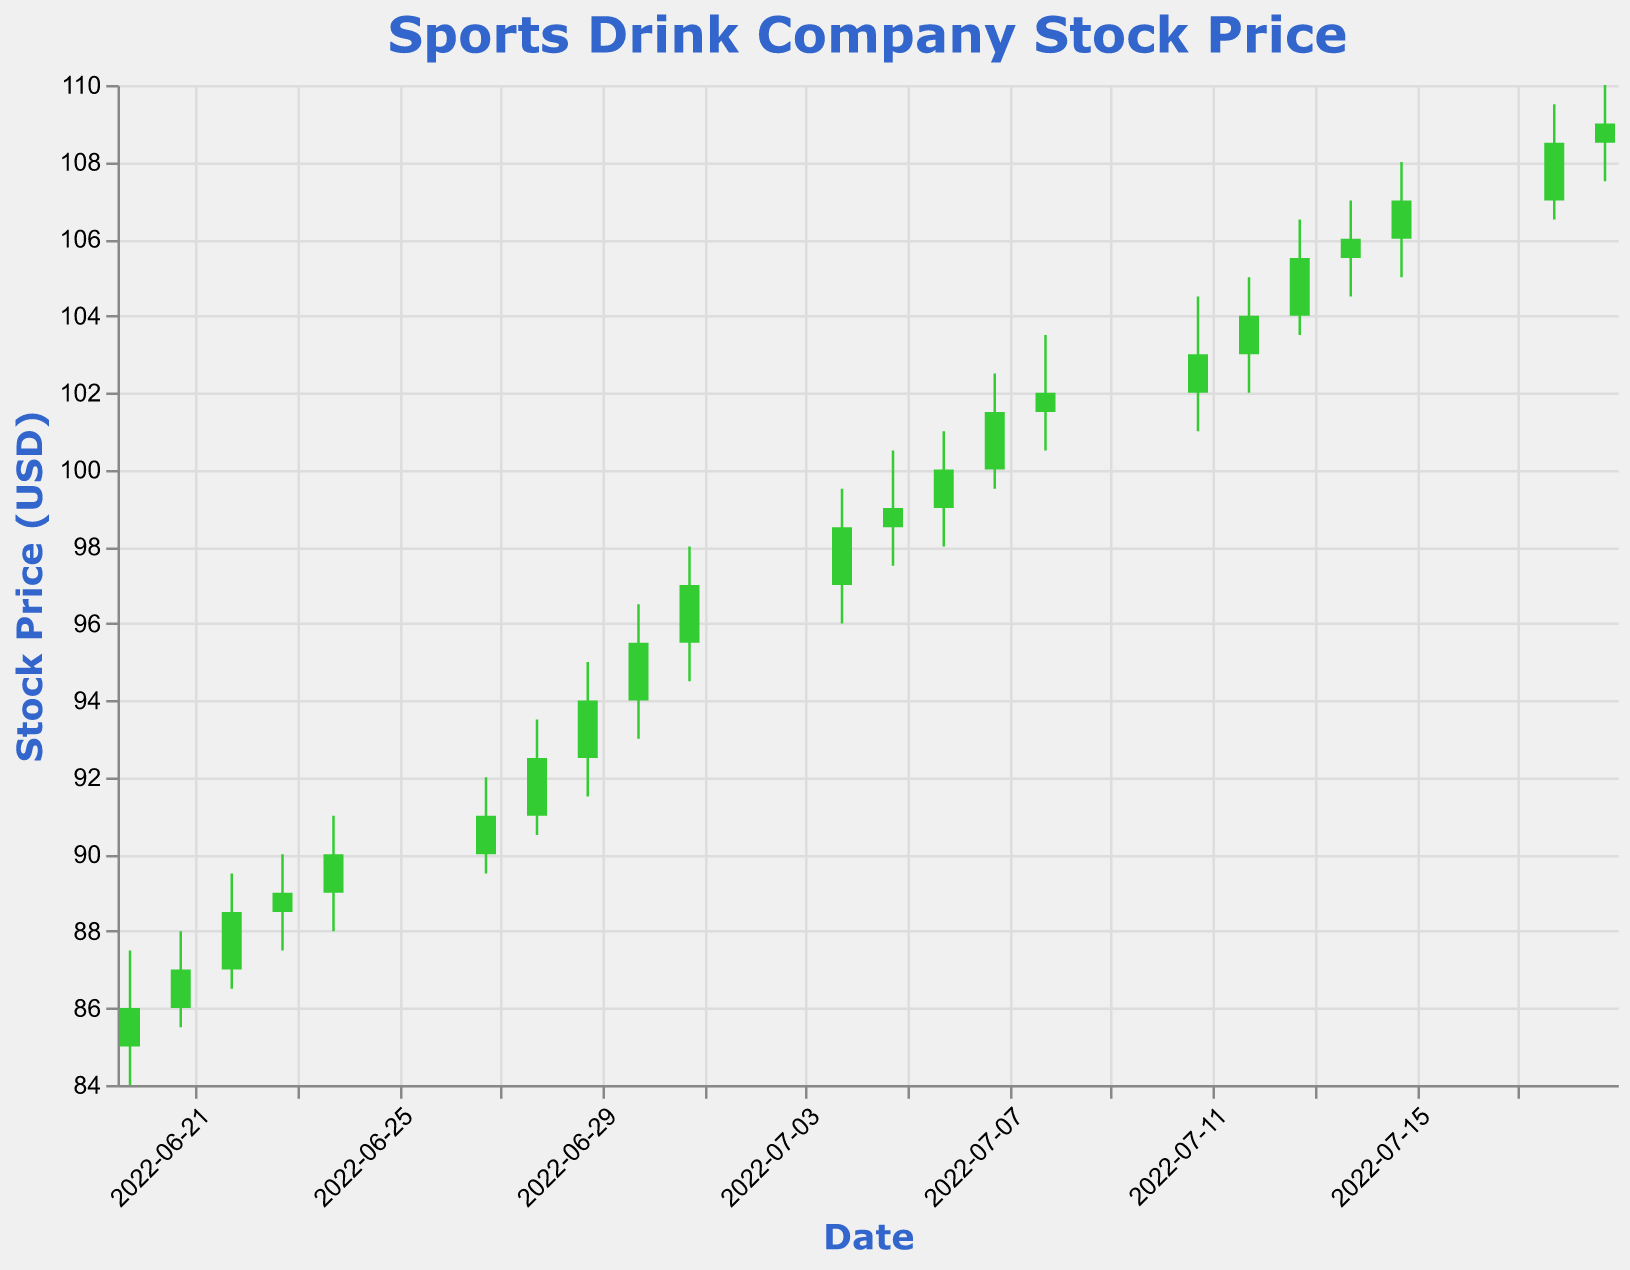When did the stock price of the sports drink company reach $100 for the first time? The stock price reached $100 for the first time on July 6, 2022, as seen from the data where the "Close" price equaled $100 on that date.
Answer: July 6, 2022 How many times did the stock price close higher than it opened between June 20, 2022, and July 19, 2022? Count the number of days where the "Close" price is greater than the "Open" price. Based on the data, this occurs on 14 days.
Answer: 14 What is the difference between the highest and lowest closing prices between June 20, 2022, and July 19, 2022? Find the maximum and minimum closing prices in the data and subtract the smallest from the largest. Maximum closing price is $109.00 and minimum closing price is $86.00. The difference is $109.00 - $86.00 = $23.00.
Answer: $23.00 Which day recorded the highest trading volume, and what was the volume? From the data, the highest trading volume was recorded on July 19, 2022, with a volume of 2,050,000.
Answer: July 19, 2022, 2,050,000 On what date did the stock price have the largest single-day increase based on the closing price? Find the day-by-day difference in "Close" price and identify the maximum. The largest single-day increase occurred on June 29, 2022, increasing from $92.50 to $94.00, an increase of $1.50.
Answer: June 29, 2022 What was the average closing price of the stock over the period from June 20, 2022, to July 19, 2022? Sum all closing prices in the period and divide by the number of data points (20 days). The sum of closing prices is $2043.50 and the average is $2043.50 / 20 = $102.175.
Answer: $102.18 How did the stock price react after the start of July compared to June? Compare the stock prices immediately before and after July 1, 2022. On June 30, the closing price was $95.50, and on July 1, it increased to $97.00, showing an initial positive reaction, followed by a steady increase through July.
Answer: Increased initially in July Between July 4, 2022, and July 8, 2022, how many days did the stock price decrease from the open to close? Within the specified dates, check how many times the "Close" price is lower than the "Open" price. It happened only once on July 5, 2022, when the closing price was $99.00 and the opening price was $98.50.
Answer: 1 day What is the trend in the trading volume from June 20, 2022, to July 19, 2022? Observing the data, the trading volume shows an increasing trend from 1,500,000 on June 20, 2022, to 2,050,000 on July 19, 2022.
Answer: Increasing Which date recorded the highest "High" price and what was that price? Find the maximum value in the "High" column. The highest "High" price was $110.00 on July 19, 2022.
Answer: July 19, $110.00 